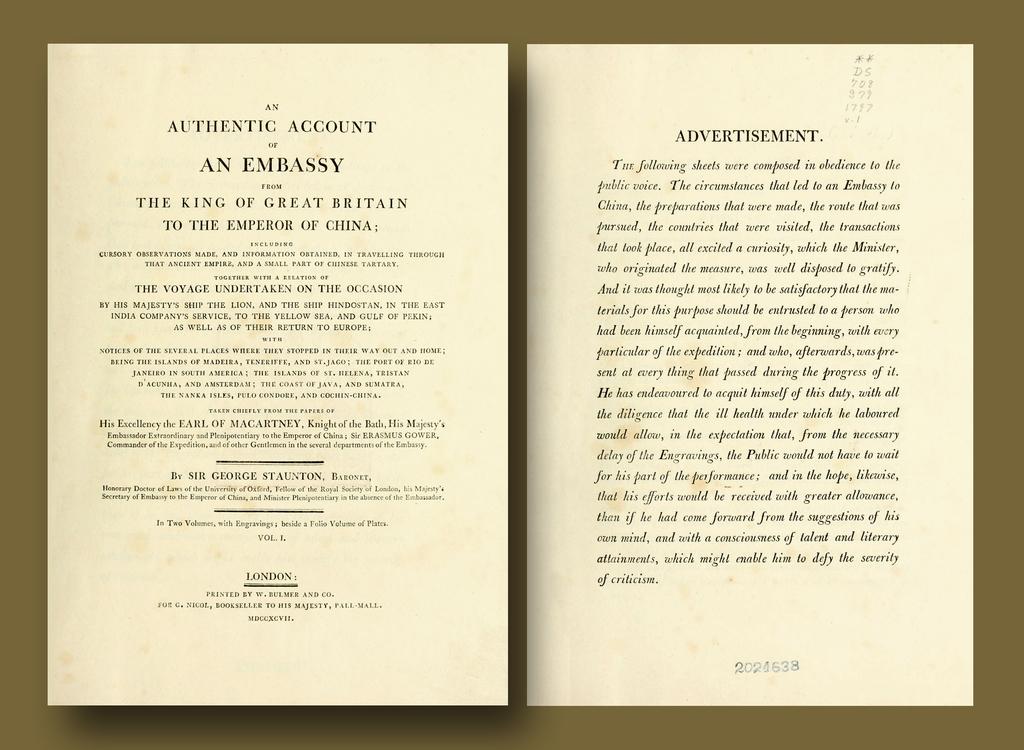What is the title on the right page?
Make the answer very short. Advertisement. 